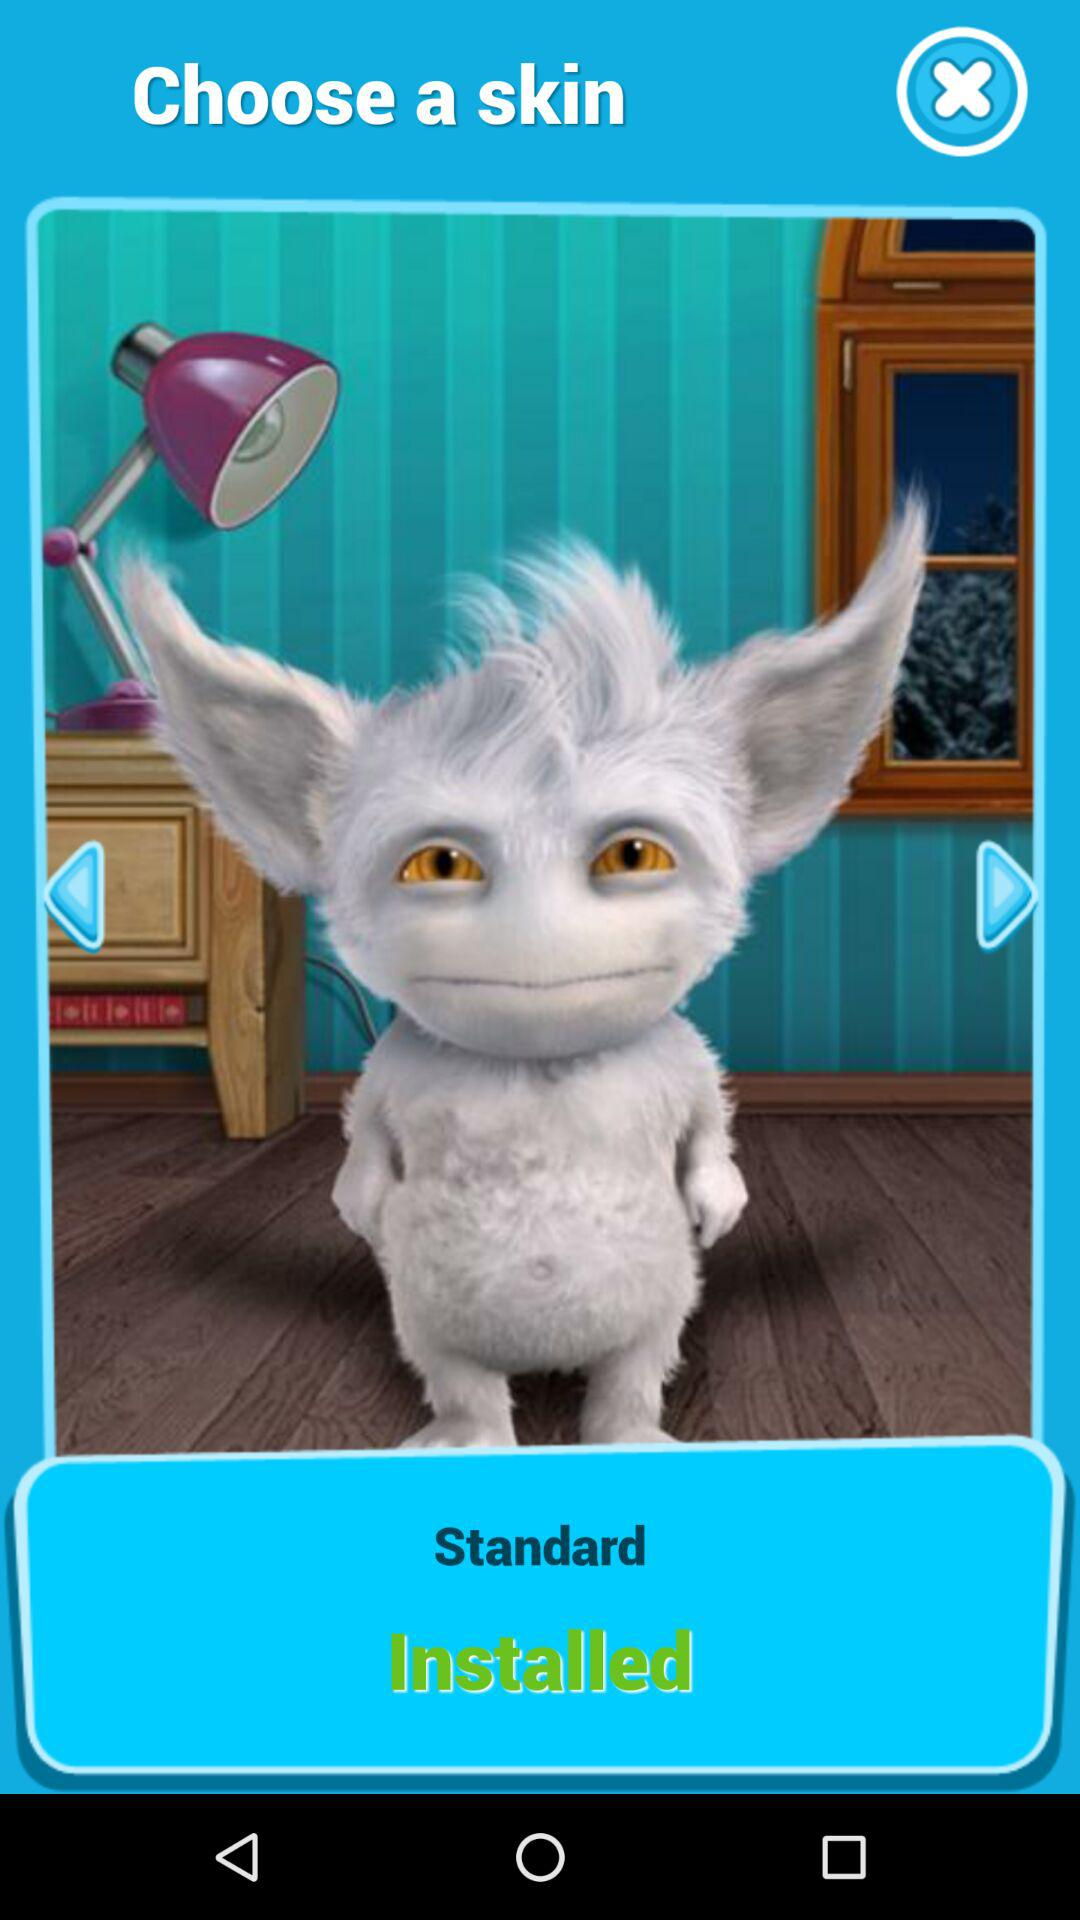What type of skin is displayed to choose? The displayed skin is "Standard". 